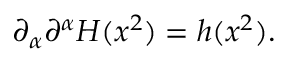<formula> <loc_0><loc_0><loc_500><loc_500>\partial _ { \alpha } \partial ^ { \alpha } H ( x ^ { 2 } ) = h ( x ^ { 2 } ) .</formula> 